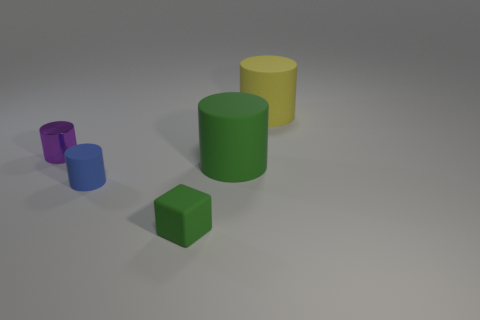Are there any other things that are the same color as the tiny rubber cube?
Your answer should be compact. Yes. How many green rubber cubes have the same size as the purple shiny object?
Your answer should be very brief. 1. How many things are either purple metal things or things in front of the metal object?
Offer a very short reply. 4. What shape is the small green object?
Offer a terse response. Cube. There is a cylinder that is the same size as the purple shiny object; what color is it?
Offer a very short reply. Blue. How many purple objects are big rubber objects or matte cubes?
Offer a terse response. 0. Is the number of small blue rubber cylinders greater than the number of things?
Your answer should be compact. No. Do the green thing on the right side of the small cube and the matte object behind the small purple shiny cylinder have the same size?
Ensure brevity in your answer.  Yes. There is a big rubber cylinder that is behind the large matte cylinder in front of the big matte object behind the metal thing; what color is it?
Give a very brief answer. Yellow. Is there a yellow shiny object of the same shape as the small blue object?
Keep it short and to the point. No. 